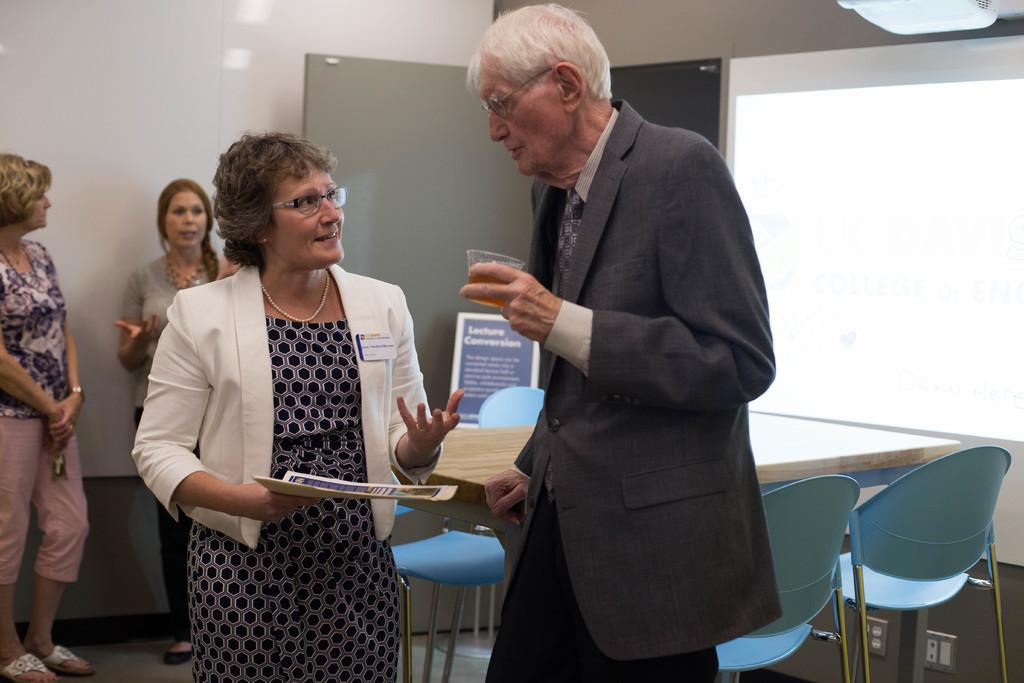Describe this image in one or two sentences. The picture is taken in a room where four people are present in the middle of the picture, one woman is standing and holding a book she is wearing a dress and white coat beside her there is one man standing with a cup in her hand and he is wearing a suit and he is taking support of the table and there are chairs and coming to the right corner of the picture there are two women standing and behind them there is a wall. 